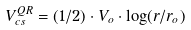<formula> <loc_0><loc_0><loc_500><loc_500>V ^ { Q R } _ { c s } = ( 1 / 2 ) \cdot V _ { o } \cdot \log ( r / r _ { o } )</formula> 